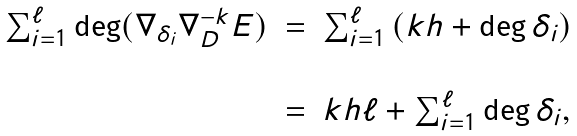Convert formula to latex. <formula><loc_0><loc_0><loc_500><loc_500>\begin{array} { c c c } \sum _ { i = 1 } ^ { \ell } \deg ( \nabla _ { \delta _ { i } } \nabla _ { D } ^ { - k } E ) & = & \sum _ { i = 1 } ^ { \ell } \left ( k h + \deg \delta _ { i } \right ) \\ & & \\ & = & k h \ell + \sum _ { i = 1 } ^ { \ell } \deg \delta _ { i } , \end{array}</formula> 